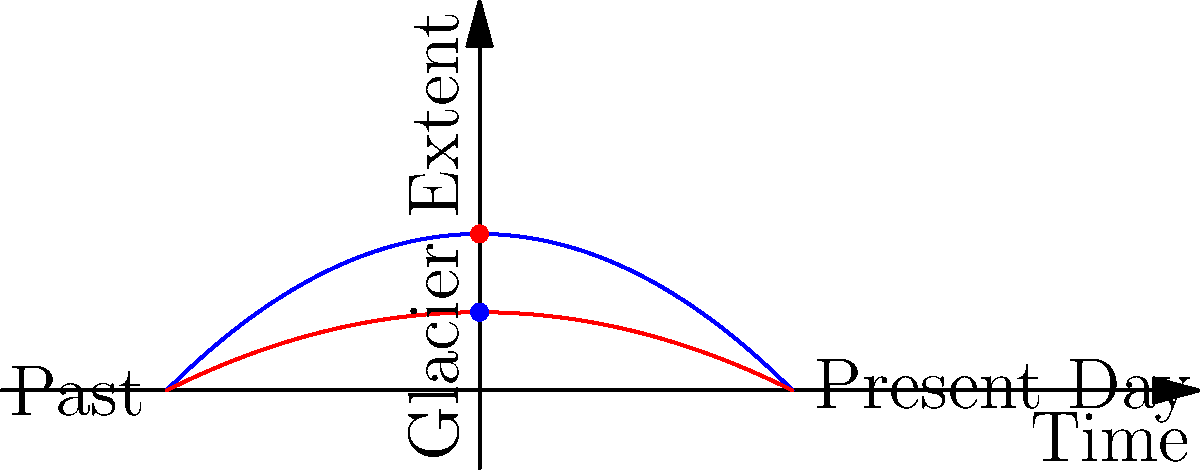In the topological representation of glacier retreat patterns over time, what does the difference between the blue and red curves primarily indicate? To answer this question, let's analyze the graph step-by-step:

1. The x-axis represents time, with the past on the left and the present day on the right.
2. The y-axis represents glacier extent, with higher values indicating larger glacier coverage.
3. We have two curves: a blue curve and a red curve.
4. Both curves show a similar parabolic shape, with the highest point (maximum glacier extent) in the past and decreasing towards the present.
5. The key difference is that the blue curve is lower than the red curve at all points in time.
6. This vertical displacement between the curves represents a change in the overall glacier extent over two different time periods or scenarios.
7. The lower position of the blue curve indicates a reduced glacier extent compared to the red curve.
8. In the context of climate change and glacier retreat, this difference likely represents the accelerated rate of glacier melting due to global warming.

Therefore, the primary indication of the difference between the blue and red curves is the increased rate of glacier retreat, presumably due to climate change effects.
Answer: Accelerated rate of glacier retreat 